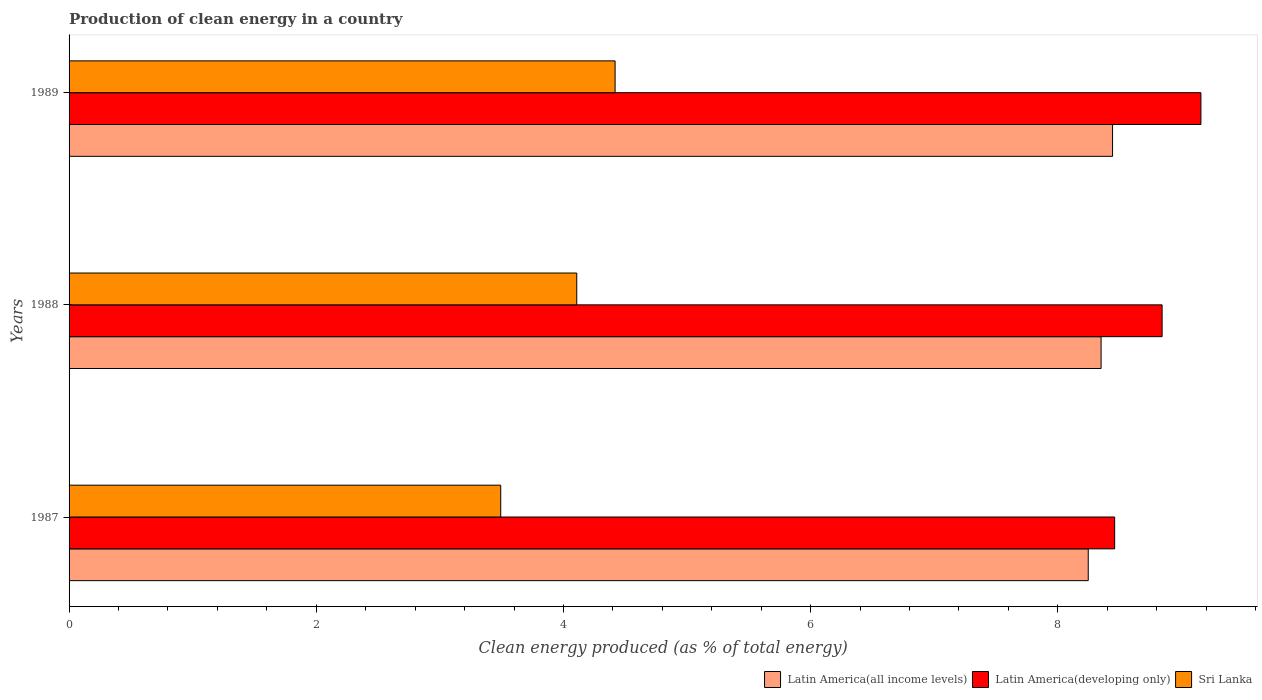How many different coloured bars are there?
Give a very brief answer. 3. How many bars are there on the 1st tick from the top?
Give a very brief answer. 3. In how many cases, is the number of bars for a given year not equal to the number of legend labels?
Offer a terse response. 0. What is the percentage of clean energy produced in Latin America(all income levels) in 1988?
Offer a terse response. 8.35. Across all years, what is the maximum percentage of clean energy produced in Sri Lanka?
Your answer should be very brief. 4.42. Across all years, what is the minimum percentage of clean energy produced in Latin America(all income levels)?
Offer a terse response. 8.25. In which year was the percentage of clean energy produced in Latin America(developing only) maximum?
Provide a succinct answer. 1989. What is the total percentage of clean energy produced in Sri Lanka in the graph?
Ensure brevity in your answer.  12.02. What is the difference between the percentage of clean energy produced in Latin America(developing only) in 1987 and that in 1989?
Your answer should be compact. -0.7. What is the difference between the percentage of clean energy produced in Sri Lanka in 1987 and the percentage of clean energy produced in Latin America(all income levels) in 1989?
Provide a succinct answer. -4.95. What is the average percentage of clean energy produced in Latin America(developing only) per year?
Ensure brevity in your answer.  8.82. In the year 1987, what is the difference between the percentage of clean energy produced in Latin America(developing only) and percentage of clean energy produced in Sri Lanka?
Your answer should be compact. 4.97. What is the ratio of the percentage of clean energy produced in Sri Lanka in 1988 to that in 1989?
Provide a short and direct response. 0.93. Is the percentage of clean energy produced in Sri Lanka in 1987 less than that in 1988?
Offer a very short reply. Yes. What is the difference between the highest and the second highest percentage of clean energy produced in Latin America(developing only)?
Your answer should be compact. 0.31. What is the difference between the highest and the lowest percentage of clean energy produced in Latin America(developing only)?
Your answer should be compact. 0.7. What does the 1st bar from the top in 1987 represents?
Make the answer very short. Sri Lanka. What does the 1st bar from the bottom in 1989 represents?
Ensure brevity in your answer.  Latin America(all income levels). Is it the case that in every year, the sum of the percentage of clean energy produced in Latin America(developing only) and percentage of clean energy produced in Sri Lanka is greater than the percentage of clean energy produced in Latin America(all income levels)?
Your answer should be very brief. Yes. What is the difference between two consecutive major ticks on the X-axis?
Ensure brevity in your answer.  2. Are the values on the major ticks of X-axis written in scientific E-notation?
Offer a terse response. No. Does the graph contain any zero values?
Offer a terse response. No. Does the graph contain grids?
Offer a terse response. No. Where does the legend appear in the graph?
Keep it short and to the point. Bottom right. What is the title of the graph?
Provide a succinct answer. Production of clean energy in a country. Does "Macao" appear as one of the legend labels in the graph?
Your answer should be compact. No. What is the label or title of the X-axis?
Give a very brief answer. Clean energy produced (as % of total energy). What is the label or title of the Y-axis?
Ensure brevity in your answer.  Years. What is the Clean energy produced (as % of total energy) of Latin America(all income levels) in 1987?
Provide a succinct answer. 8.25. What is the Clean energy produced (as % of total energy) of Latin America(developing only) in 1987?
Your answer should be compact. 8.46. What is the Clean energy produced (as % of total energy) in Sri Lanka in 1987?
Your response must be concise. 3.49. What is the Clean energy produced (as % of total energy) in Latin America(all income levels) in 1988?
Your answer should be compact. 8.35. What is the Clean energy produced (as % of total energy) of Latin America(developing only) in 1988?
Offer a terse response. 8.84. What is the Clean energy produced (as % of total energy) in Sri Lanka in 1988?
Your response must be concise. 4.11. What is the Clean energy produced (as % of total energy) of Latin America(all income levels) in 1989?
Your response must be concise. 8.44. What is the Clean energy produced (as % of total energy) in Latin America(developing only) in 1989?
Your answer should be compact. 9.16. What is the Clean energy produced (as % of total energy) in Sri Lanka in 1989?
Keep it short and to the point. 4.42. Across all years, what is the maximum Clean energy produced (as % of total energy) in Latin America(all income levels)?
Give a very brief answer. 8.44. Across all years, what is the maximum Clean energy produced (as % of total energy) in Latin America(developing only)?
Give a very brief answer. 9.16. Across all years, what is the maximum Clean energy produced (as % of total energy) of Sri Lanka?
Offer a terse response. 4.42. Across all years, what is the minimum Clean energy produced (as % of total energy) of Latin America(all income levels)?
Provide a short and direct response. 8.25. Across all years, what is the minimum Clean energy produced (as % of total energy) in Latin America(developing only)?
Keep it short and to the point. 8.46. Across all years, what is the minimum Clean energy produced (as % of total energy) in Sri Lanka?
Provide a short and direct response. 3.49. What is the total Clean energy produced (as % of total energy) of Latin America(all income levels) in the graph?
Give a very brief answer. 25.04. What is the total Clean energy produced (as % of total energy) of Latin America(developing only) in the graph?
Make the answer very short. 26.46. What is the total Clean energy produced (as % of total energy) of Sri Lanka in the graph?
Provide a succinct answer. 12.02. What is the difference between the Clean energy produced (as % of total energy) in Latin America(all income levels) in 1987 and that in 1988?
Offer a terse response. -0.1. What is the difference between the Clean energy produced (as % of total energy) of Latin America(developing only) in 1987 and that in 1988?
Offer a terse response. -0.38. What is the difference between the Clean energy produced (as % of total energy) in Sri Lanka in 1987 and that in 1988?
Give a very brief answer. -0.61. What is the difference between the Clean energy produced (as % of total energy) of Latin America(all income levels) in 1987 and that in 1989?
Make the answer very short. -0.2. What is the difference between the Clean energy produced (as % of total energy) in Latin America(developing only) in 1987 and that in 1989?
Make the answer very short. -0.7. What is the difference between the Clean energy produced (as % of total energy) of Sri Lanka in 1987 and that in 1989?
Make the answer very short. -0.93. What is the difference between the Clean energy produced (as % of total energy) in Latin America(all income levels) in 1988 and that in 1989?
Provide a short and direct response. -0.09. What is the difference between the Clean energy produced (as % of total energy) in Latin America(developing only) in 1988 and that in 1989?
Provide a short and direct response. -0.31. What is the difference between the Clean energy produced (as % of total energy) of Sri Lanka in 1988 and that in 1989?
Make the answer very short. -0.31. What is the difference between the Clean energy produced (as % of total energy) in Latin America(all income levels) in 1987 and the Clean energy produced (as % of total energy) in Latin America(developing only) in 1988?
Your answer should be compact. -0.6. What is the difference between the Clean energy produced (as % of total energy) in Latin America(all income levels) in 1987 and the Clean energy produced (as % of total energy) in Sri Lanka in 1988?
Your answer should be very brief. 4.14. What is the difference between the Clean energy produced (as % of total energy) in Latin America(developing only) in 1987 and the Clean energy produced (as % of total energy) in Sri Lanka in 1988?
Keep it short and to the point. 4.35. What is the difference between the Clean energy produced (as % of total energy) in Latin America(all income levels) in 1987 and the Clean energy produced (as % of total energy) in Latin America(developing only) in 1989?
Provide a short and direct response. -0.91. What is the difference between the Clean energy produced (as % of total energy) of Latin America(all income levels) in 1987 and the Clean energy produced (as % of total energy) of Sri Lanka in 1989?
Offer a terse response. 3.83. What is the difference between the Clean energy produced (as % of total energy) in Latin America(developing only) in 1987 and the Clean energy produced (as % of total energy) in Sri Lanka in 1989?
Your response must be concise. 4.04. What is the difference between the Clean energy produced (as % of total energy) of Latin America(all income levels) in 1988 and the Clean energy produced (as % of total energy) of Latin America(developing only) in 1989?
Your response must be concise. -0.81. What is the difference between the Clean energy produced (as % of total energy) in Latin America(all income levels) in 1988 and the Clean energy produced (as % of total energy) in Sri Lanka in 1989?
Your response must be concise. 3.93. What is the difference between the Clean energy produced (as % of total energy) in Latin America(developing only) in 1988 and the Clean energy produced (as % of total energy) in Sri Lanka in 1989?
Provide a short and direct response. 4.43. What is the average Clean energy produced (as % of total energy) in Latin America(all income levels) per year?
Offer a terse response. 8.35. What is the average Clean energy produced (as % of total energy) of Latin America(developing only) per year?
Make the answer very short. 8.82. What is the average Clean energy produced (as % of total energy) in Sri Lanka per year?
Make the answer very short. 4.01. In the year 1987, what is the difference between the Clean energy produced (as % of total energy) of Latin America(all income levels) and Clean energy produced (as % of total energy) of Latin America(developing only)?
Keep it short and to the point. -0.21. In the year 1987, what is the difference between the Clean energy produced (as % of total energy) of Latin America(all income levels) and Clean energy produced (as % of total energy) of Sri Lanka?
Ensure brevity in your answer.  4.75. In the year 1987, what is the difference between the Clean energy produced (as % of total energy) of Latin America(developing only) and Clean energy produced (as % of total energy) of Sri Lanka?
Keep it short and to the point. 4.97. In the year 1988, what is the difference between the Clean energy produced (as % of total energy) of Latin America(all income levels) and Clean energy produced (as % of total energy) of Latin America(developing only)?
Make the answer very short. -0.49. In the year 1988, what is the difference between the Clean energy produced (as % of total energy) in Latin America(all income levels) and Clean energy produced (as % of total energy) in Sri Lanka?
Provide a succinct answer. 4.24. In the year 1988, what is the difference between the Clean energy produced (as % of total energy) in Latin America(developing only) and Clean energy produced (as % of total energy) in Sri Lanka?
Provide a succinct answer. 4.74. In the year 1989, what is the difference between the Clean energy produced (as % of total energy) of Latin America(all income levels) and Clean energy produced (as % of total energy) of Latin America(developing only)?
Give a very brief answer. -0.71. In the year 1989, what is the difference between the Clean energy produced (as % of total energy) of Latin America(all income levels) and Clean energy produced (as % of total energy) of Sri Lanka?
Provide a short and direct response. 4.02. In the year 1989, what is the difference between the Clean energy produced (as % of total energy) of Latin America(developing only) and Clean energy produced (as % of total energy) of Sri Lanka?
Keep it short and to the point. 4.74. What is the ratio of the Clean energy produced (as % of total energy) in Latin America(all income levels) in 1987 to that in 1988?
Provide a succinct answer. 0.99. What is the ratio of the Clean energy produced (as % of total energy) of Latin America(developing only) in 1987 to that in 1988?
Your answer should be compact. 0.96. What is the ratio of the Clean energy produced (as % of total energy) in Sri Lanka in 1987 to that in 1988?
Your answer should be very brief. 0.85. What is the ratio of the Clean energy produced (as % of total energy) in Latin America(all income levels) in 1987 to that in 1989?
Offer a terse response. 0.98. What is the ratio of the Clean energy produced (as % of total energy) in Latin America(developing only) in 1987 to that in 1989?
Offer a very short reply. 0.92. What is the ratio of the Clean energy produced (as % of total energy) of Sri Lanka in 1987 to that in 1989?
Your response must be concise. 0.79. What is the ratio of the Clean energy produced (as % of total energy) of Latin America(all income levels) in 1988 to that in 1989?
Offer a terse response. 0.99. What is the ratio of the Clean energy produced (as % of total energy) in Latin America(developing only) in 1988 to that in 1989?
Keep it short and to the point. 0.97. What is the ratio of the Clean energy produced (as % of total energy) in Sri Lanka in 1988 to that in 1989?
Offer a terse response. 0.93. What is the difference between the highest and the second highest Clean energy produced (as % of total energy) of Latin America(all income levels)?
Make the answer very short. 0.09. What is the difference between the highest and the second highest Clean energy produced (as % of total energy) of Latin America(developing only)?
Provide a short and direct response. 0.31. What is the difference between the highest and the second highest Clean energy produced (as % of total energy) of Sri Lanka?
Keep it short and to the point. 0.31. What is the difference between the highest and the lowest Clean energy produced (as % of total energy) of Latin America(all income levels)?
Your answer should be compact. 0.2. What is the difference between the highest and the lowest Clean energy produced (as % of total energy) of Latin America(developing only)?
Ensure brevity in your answer.  0.7. What is the difference between the highest and the lowest Clean energy produced (as % of total energy) of Sri Lanka?
Offer a very short reply. 0.93. 